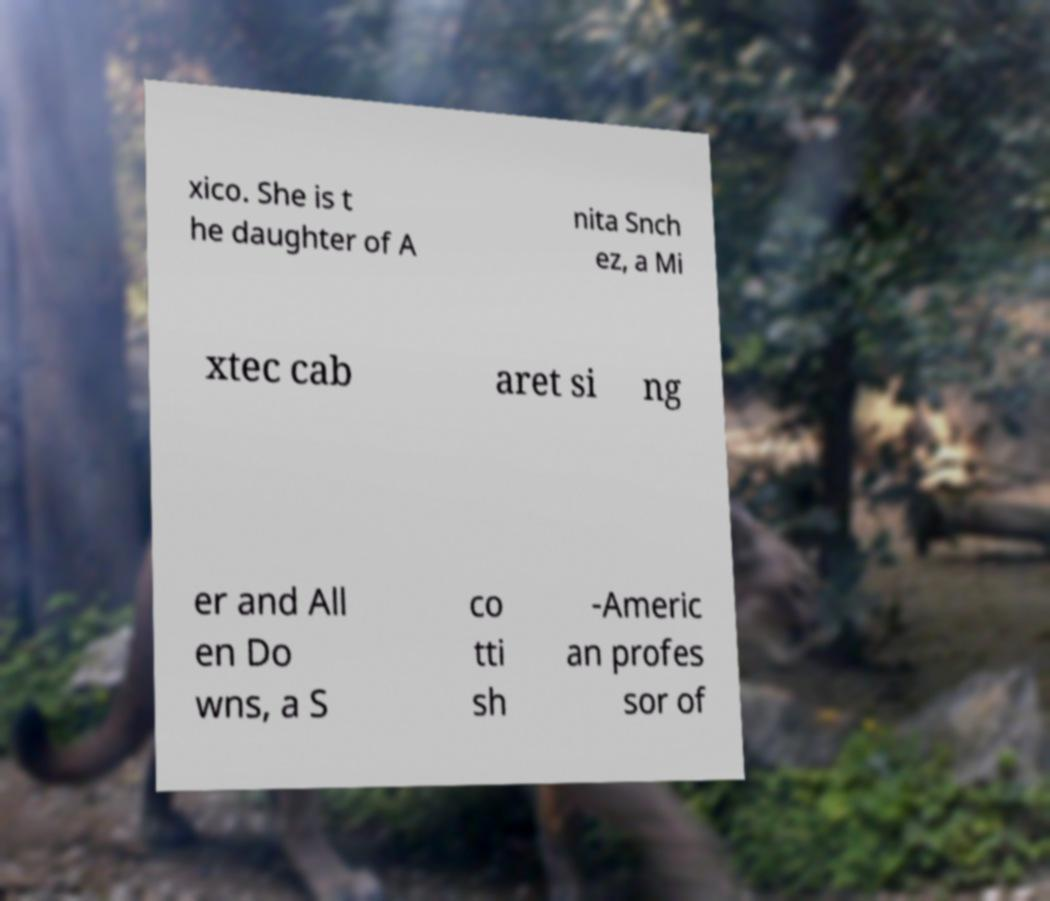There's text embedded in this image that I need extracted. Can you transcribe it verbatim? xico. She is t he daughter of A nita Snch ez, a Mi xtec cab aret si ng er and All en Do wns, a S co tti sh -Americ an profes sor of 